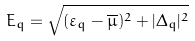Convert formula to latex. <formula><loc_0><loc_0><loc_500><loc_500>E _ { q } = \sqrt { ( \varepsilon _ { q } - \overline { \mu } ) ^ { 2 } + | \Delta _ { q } | ^ { 2 } }</formula> 